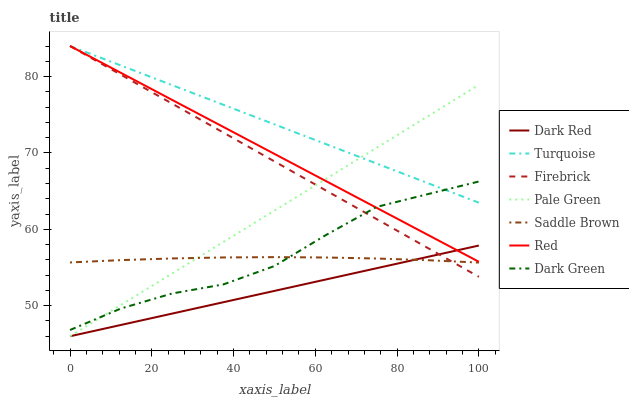Does Dark Red have the minimum area under the curve?
Answer yes or no. Yes. Does Turquoise have the maximum area under the curve?
Answer yes or no. Yes. Does Firebrick have the minimum area under the curve?
Answer yes or no. No. Does Firebrick have the maximum area under the curve?
Answer yes or no. No. Is Firebrick the smoothest?
Answer yes or no. Yes. Is Dark Green the roughest?
Answer yes or no. Yes. Is Dark Red the smoothest?
Answer yes or no. No. Is Dark Red the roughest?
Answer yes or no. No. Does Dark Red have the lowest value?
Answer yes or no. Yes. Does Firebrick have the lowest value?
Answer yes or no. No. Does Red have the highest value?
Answer yes or no. Yes. Does Dark Red have the highest value?
Answer yes or no. No. Is Dark Red less than Dark Green?
Answer yes or no. Yes. Is Turquoise greater than Dark Red?
Answer yes or no. Yes. Does Dark Red intersect Pale Green?
Answer yes or no. Yes. Is Dark Red less than Pale Green?
Answer yes or no. No. Is Dark Red greater than Pale Green?
Answer yes or no. No. Does Dark Red intersect Dark Green?
Answer yes or no. No. 